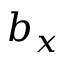Convert formula to latex. <formula><loc_0><loc_0><loc_500><loc_500>b _ { x }</formula> 